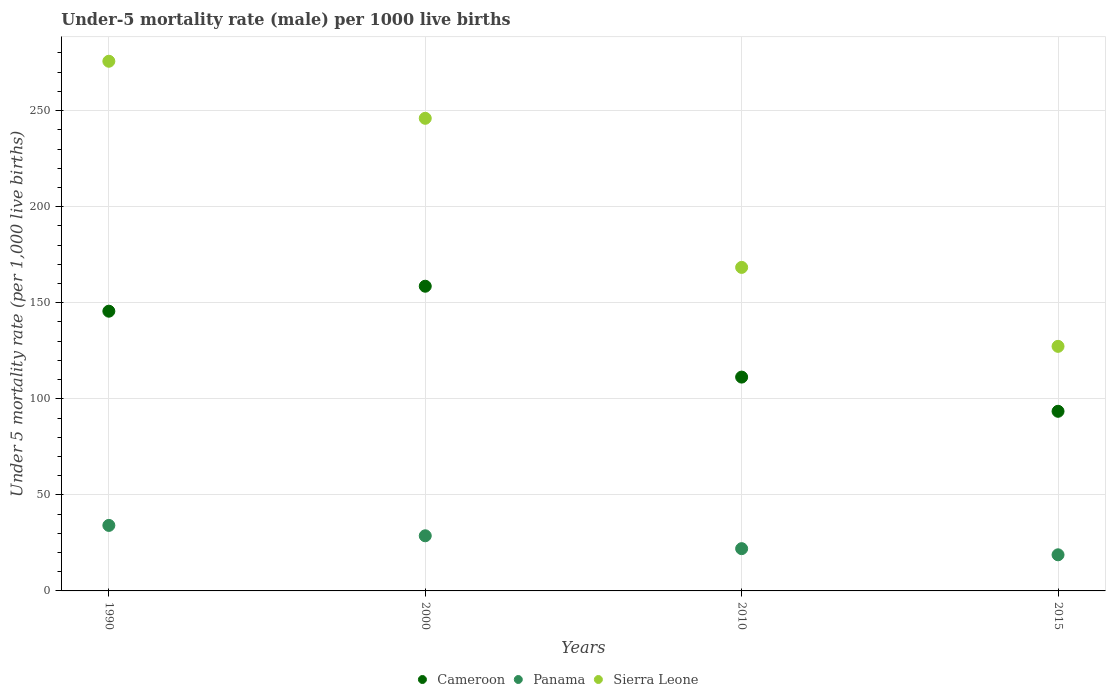Is the number of dotlines equal to the number of legend labels?
Your response must be concise. Yes. What is the under-five mortality rate in Panama in 2015?
Provide a succinct answer. 18.8. Across all years, what is the maximum under-five mortality rate in Panama?
Offer a terse response. 34.1. Across all years, what is the minimum under-five mortality rate in Cameroon?
Provide a succinct answer. 93.5. In which year was the under-five mortality rate in Cameroon minimum?
Keep it short and to the point. 2015. What is the total under-five mortality rate in Cameroon in the graph?
Your answer should be very brief. 509. What is the difference between the under-five mortality rate in Sierra Leone in 1990 and that in 2000?
Provide a succinct answer. 29.7. What is the difference between the under-five mortality rate in Cameroon in 2015 and the under-five mortality rate in Panama in 1990?
Provide a short and direct response. 59.4. What is the average under-five mortality rate in Panama per year?
Offer a terse response. 25.9. In the year 2010, what is the difference between the under-five mortality rate in Sierra Leone and under-five mortality rate in Panama?
Your response must be concise. 146.4. In how many years, is the under-five mortality rate in Cameroon greater than 130?
Your response must be concise. 2. What is the ratio of the under-five mortality rate in Cameroon in 1990 to that in 2010?
Give a very brief answer. 1.31. Is the difference between the under-five mortality rate in Sierra Leone in 2010 and 2015 greater than the difference between the under-five mortality rate in Panama in 2010 and 2015?
Offer a very short reply. Yes. What is the difference between the highest and the second highest under-five mortality rate in Sierra Leone?
Ensure brevity in your answer.  29.7. What is the difference between the highest and the lowest under-five mortality rate in Sierra Leone?
Provide a short and direct response. 148.4. In how many years, is the under-five mortality rate in Sierra Leone greater than the average under-five mortality rate in Sierra Leone taken over all years?
Offer a terse response. 2. Is the sum of the under-five mortality rate in Panama in 2010 and 2015 greater than the maximum under-five mortality rate in Cameroon across all years?
Make the answer very short. No. Is the under-five mortality rate in Panama strictly less than the under-five mortality rate in Sierra Leone over the years?
Make the answer very short. Yes. How many dotlines are there?
Your answer should be compact. 3. How many years are there in the graph?
Provide a short and direct response. 4. Does the graph contain any zero values?
Ensure brevity in your answer.  No. Does the graph contain grids?
Give a very brief answer. Yes. Where does the legend appear in the graph?
Make the answer very short. Bottom center. How many legend labels are there?
Make the answer very short. 3. How are the legend labels stacked?
Ensure brevity in your answer.  Horizontal. What is the title of the graph?
Your response must be concise. Under-5 mortality rate (male) per 1000 live births. Does "Liberia" appear as one of the legend labels in the graph?
Your answer should be compact. No. What is the label or title of the X-axis?
Offer a terse response. Years. What is the label or title of the Y-axis?
Your response must be concise. Under 5 mortality rate (per 1,0 live births). What is the Under 5 mortality rate (per 1,000 live births) of Cameroon in 1990?
Offer a terse response. 145.6. What is the Under 5 mortality rate (per 1,000 live births) in Panama in 1990?
Ensure brevity in your answer.  34.1. What is the Under 5 mortality rate (per 1,000 live births) in Sierra Leone in 1990?
Your response must be concise. 275.7. What is the Under 5 mortality rate (per 1,000 live births) of Cameroon in 2000?
Provide a succinct answer. 158.6. What is the Under 5 mortality rate (per 1,000 live births) of Panama in 2000?
Provide a succinct answer. 28.7. What is the Under 5 mortality rate (per 1,000 live births) of Sierra Leone in 2000?
Your response must be concise. 246. What is the Under 5 mortality rate (per 1,000 live births) in Cameroon in 2010?
Make the answer very short. 111.3. What is the Under 5 mortality rate (per 1,000 live births) of Sierra Leone in 2010?
Your answer should be compact. 168.4. What is the Under 5 mortality rate (per 1,000 live births) of Cameroon in 2015?
Offer a very short reply. 93.5. What is the Under 5 mortality rate (per 1,000 live births) of Panama in 2015?
Give a very brief answer. 18.8. What is the Under 5 mortality rate (per 1,000 live births) of Sierra Leone in 2015?
Ensure brevity in your answer.  127.3. Across all years, what is the maximum Under 5 mortality rate (per 1,000 live births) of Cameroon?
Ensure brevity in your answer.  158.6. Across all years, what is the maximum Under 5 mortality rate (per 1,000 live births) in Panama?
Make the answer very short. 34.1. Across all years, what is the maximum Under 5 mortality rate (per 1,000 live births) of Sierra Leone?
Offer a terse response. 275.7. Across all years, what is the minimum Under 5 mortality rate (per 1,000 live births) of Cameroon?
Your answer should be compact. 93.5. Across all years, what is the minimum Under 5 mortality rate (per 1,000 live births) of Panama?
Keep it short and to the point. 18.8. Across all years, what is the minimum Under 5 mortality rate (per 1,000 live births) of Sierra Leone?
Provide a short and direct response. 127.3. What is the total Under 5 mortality rate (per 1,000 live births) of Cameroon in the graph?
Your answer should be very brief. 509. What is the total Under 5 mortality rate (per 1,000 live births) in Panama in the graph?
Your answer should be very brief. 103.6. What is the total Under 5 mortality rate (per 1,000 live births) in Sierra Leone in the graph?
Your answer should be very brief. 817.4. What is the difference between the Under 5 mortality rate (per 1,000 live births) in Sierra Leone in 1990 and that in 2000?
Ensure brevity in your answer.  29.7. What is the difference between the Under 5 mortality rate (per 1,000 live births) in Cameroon in 1990 and that in 2010?
Keep it short and to the point. 34.3. What is the difference between the Under 5 mortality rate (per 1,000 live births) in Panama in 1990 and that in 2010?
Keep it short and to the point. 12.1. What is the difference between the Under 5 mortality rate (per 1,000 live births) of Sierra Leone in 1990 and that in 2010?
Your answer should be compact. 107.3. What is the difference between the Under 5 mortality rate (per 1,000 live births) of Cameroon in 1990 and that in 2015?
Offer a terse response. 52.1. What is the difference between the Under 5 mortality rate (per 1,000 live births) of Panama in 1990 and that in 2015?
Your answer should be very brief. 15.3. What is the difference between the Under 5 mortality rate (per 1,000 live births) in Sierra Leone in 1990 and that in 2015?
Make the answer very short. 148.4. What is the difference between the Under 5 mortality rate (per 1,000 live births) of Cameroon in 2000 and that in 2010?
Keep it short and to the point. 47.3. What is the difference between the Under 5 mortality rate (per 1,000 live births) of Sierra Leone in 2000 and that in 2010?
Give a very brief answer. 77.6. What is the difference between the Under 5 mortality rate (per 1,000 live births) of Cameroon in 2000 and that in 2015?
Make the answer very short. 65.1. What is the difference between the Under 5 mortality rate (per 1,000 live births) in Panama in 2000 and that in 2015?
Keep it short and to the point. 9.9. What is the difference between the Under 5 mortality rate (per 1,000 live births) of Sierra Leone in 2000 and that in 2015?
Your answer should be very brief. 118.7. What is the difference between the Under 5 mortality rate (per 1,000 live births) in Cameroon in 2010 and that in 2015?
Your answer should be very brief. 17.8. What is the difference between the Under 5 mortality rate (per 1,000 live births) of Panama in 2010 and that in 2015?
Offer a very short reply. 3.2. What is the difference between the Under 5 mortality rate (per 1,000 live births) of Sierra Leone in 2010 and that in 2015?
Offer a terse response. 41.1. What is the difference between the Under 5 mortality rate (per 1,000 live births) of Cameroon in 1990 and the Under 5 mortality rate (per 1,000 live births) of Panama in 2000?
Make the answer very short. 116.9. What is the difference between the Under 5 mortality rate (per 1,000 live births) of Cameroon in 1990 and the Under 5 mortality rate (per 1,000 live births) of Sierra Leone in 2000?
Your answer should be very brief. -100.4. What is the difference between the Under 5 mortality rate (per 1,000 live births) of Panama in 1990 and the Under 5 mortality rate (per 1,000 live births) of Sierra Leone in 2000?
Ensure brevity in your answer.  -211.9. What is the difference between the Under 5 mortality rate (per 1,000 live births) in Cameroon in 1990 and the Under 5 mortality rate (per 1,000 live births) in Panama in 2010?
Offer a terse response. 123.6. What is the difference between the Under 5 mortality rate (per 1,000 live births) in Cameroon in 1990 and the Under 5 mortality rate (per 1,000 live births) in Sierra Leone in 2010?
Give a very brief answer. -22.8. What is the difference between the Under 5 mortality rate (per 1,000 live births) in Panama in 1990 and the Under 5 mortality rate (per 1,000 live births) in Sierra Leone in 2010?
Your response must be concise. -134.3. What is the difference between the Under 5 mortality rate (per 1,000 live births) in Cameroon in 1990 and the Under 5 mortality rate (per 1,000 live births) in Panama in 2015?
Your answer should be very brief. 126.8. What is the difference between the Under 5 mortality rate (per 1,000 live births) in Panama in 1990 and the Under 5 mortality rate (per 1,000 live births) in Sierra Leone in 2015?
Your response must be concise. -93.2. What is the difference between the Under 5 mortality rate (per 1,000 live births) of Cameroon in 2000 and the Under 5 mortality rate (per 1,000 live births) of Panama in 2010?
Ensure brevity in your answer.  136.6. What is the difference between the Under 5 mortality rate (per 1,000 live births) of Cameroon in 2000 and the Under 5 mortality rate (per 1,000 live births) of Sierra Leone in 2010?
Give a very brief answer. -9.8. What is the difference between the Under 5 mortality rate (per 1,000 live births) of Panama in 2000 and the Under 5 mortality rate (per 1,000 live births) of Sierra Leone in 2010?
Ensure brevity in your answer.  -139.7. What is the difference between the Under 5 mortality rate (per 1,000 live births) in Cameroon in 2000 and the Under 5 mortality rate (per 1,000 live births) in Panama in 2015?
Provide a succinct answer. 139.8. What is the difference between the Under 5 mortality rate (per 1,000 live births) in Cameroon in 2000 and the Under 5 mortality rate (per 1,000 live births) in Sierra Leone in 2015?
Offer a terse response. 31.3. What is the difference between the Under 5 mortality rate (per 1,000 live births) in Panama in 2000 and the Under 5 mortality rate (per 1,000 live births) in Sierra Leone in 2015?
Your answer should be compact. -98.6. What is the difference between the Under 5 mortality rate (per 1,000 live births) in Cameroon in 2010 and the Under 5 mortality rate (per 1,000 live births) in Panama in 2015?
Keep it short and to the point. 92.5. What is the difference between the Under 5 mortality rate (per 1,000 live births) of Cameroon in 2010 and the Under 5 mortality rate (per 1,000 live births) of Sierra Leone in 2015?
Your answer should be compact. -16. What is the difference between the Under 5 mortality rate (per 1,000 live births) in Panama in 2010 and the Under 5 mortality rate (per 1,000 live births) in Sierra Leone in 2015?
Offer a terse response. -105.3. What is the average Under 5 mortality rate (per 1,000 live births) in Cameroon per year?
Give a very brief answer. 127.25. What is the average Under 5 mortality rate (per 1,000 live births) of Panama per year?
Give a very brief answer. 25.9. What is the average Under 5 mortality rate (per 1,000 live births) in Sierra Leone per year?
Your answer should be compact. 204.35. In the year 1990, what is the difference between the Under 5 mortality rate (per 1,000 live births) in Cameroon and Under 5 mortality rate (per 1,000 live births) in Panama?
Your answer should be very brief. 111.5. In the year 1990, what is the difference between the Under 5 mortality rate (per 1,000 live births) of Cameroon and Under 5 mortality rate (per 1,000 live births) of Sierra Leone?
Offer a terse response. -130.1. In the year 1990, what is the difference between the Under 5 mortality rate (per 1,000 live births) in Panama and Under 5 mortality rate (per 1,000 live births) in Sierra Leone?
Your answer should be compact. -241.6. In the year 2000, what is the difference between the Under 5 mortality rate (per 1,000 live births) in Cameroon and Under 5 mortality rate (per 1,000 live births) in Panama?
Provide a short and direct response. 129.9. In the year 2000, what is the difference between the Under 5 mortality rate (per 1,000 live births) of Cameroon and Under 5 mortality rate (per 1,000 live births) of Sierra Leone?
Make the answer very short. -87.4. In the year 2000, what is the difference between the Under 5 mortality rate (per 1,000 live births) of Panama and Under 5 mortality rate (per 1,000 live births) of Sierra Leone?
Give a very brief answer. -217.3. In the year 2010, what is the difference between the Under 5 mortality rate (per 1,000 live births) in Cameroon and Under 5 mortality rate (per 1,000 live births) in Panama?
Ensure brevity in your answer.  89.3. In the year 2010, what is the difference between the Under 5 mortality rate (per 1,000 live births) in Cameroon and Under 5 mortality rate (per 1,000 live births) in Sierra Leone?
Your answer should be compact. -57.1. In the year 2010, what is the difference between the Under 5 mortality rate (per 1,000 live births) in Panama and Under 5 mortality rate (per 1,000 live births) in Sierra Leone?
Offer a very short reply. -146.4. In the year 2015, what is the difference between the Under 5 mortality rate (per 1,000 live births) in Cameroon and Under 5 mortality rate (per 1,000 live births) in Panama?
Your answer should be very brief. 74.7. In the year 2015, what is the difference between the Under 5 mortality rate (per 1,000 live births) of Cameroon and Under 5 mortality rate (per 1,000 live births) of Sierra Leone?
Make the answer very short. -33.8. In the year 2015, what is the difference between the Under 5 mortality rate (per 1,000 live births) in Panama and Under 5 mortality rate (per 1,000 live births) in Sierra Leone?
Provide a short and direct response. -108.5. What is the ratio of the Under 5 mortality rate (per 1,000 live births) in Cameroon in 1990 to that in 2000?
Offer a very short reply. 0.92. What is the ratio of the Under 5 mortality rate (per 1,000 live births) of Panama in 1990 to that in 2000?
Offer a very short reply. 1.19. What is the ratio of the Under 5 mortality rate (per 1,000 live births) in Sierra Leone in 1990 to that in 2000?
Your answer should be compact. 1.12. What is the ratio of the Under 5 mortality rate (per 1,000 live births) in Cameroon in 1990 to that in 2010?
Your response must be concise. 1.31. What is the ratio of the Under 5 mortality rate (per 1,000 live births) of Panama in 1990 to that in 2010?
Provide a short and direct response. 1.55. What is the ratio of the Under 5 mortality rate (per 1,000 live births) of Sierra Leone in 1990 to that in 2010?
Ensure brevity in your answer.  1.64. What is the ratio of the Under 5 mortality rate (per 1,000 live births) in Cameroon in 1990 to that in 2015?
Offer a terse response. 1.56. What is the ratio of the Under 5 mortality rate (per 1,000 live births) in Panama in 1990 to that in 2015?
Provide a succinct answer. 1.81. What is the ratio of the Under 5 mortality rate (per 1,000 live births) of Sierra Leone in 1990 to that in 2015?
Make the answer very short. 2.17. What is the ratio of the Under 5 mortality rate (per 1,000 live births) in Cameroon in 2000 to that in 2010?
Your response must be concise. 1.43. What is the ratio of the Under 5 mortality rate (per 1,000 live births) in Panama in 2000 to that in 2010?
Your answer should be compact. 1.3. What is the ratio of the Under 5 mortality rate (per 1,000 live births) in Sierra Leone in 2000 to that in 2010?
Keep it short and to the point. 1.46. What is the ratio of the Under 5 mortality rate (per 1,000 live births) in Cameroon in 2000 to that in 2015?
Ensure brevity in your answer.  1.7. What is the ratio of the Under 5 mortality rate (per 1,000 live births) in Panama in 2000 to that in 2015?
Give a very brief answer. 1.53. What is the ratio of the Under 5 mortality rate (per 1,000 live births) in Sierra Leone in 2000 to that in 2015?
Keep it short and to the point. 1.93. What is the ratio of the Under 5 mortality rate (per 1,000 live births) in Cameroon in 2010 to that in 2015?
Keep it short and to the point. 1.19. What is the ratio of the Under 5 mortality rate (per 1,000 live births) of Panama in 2010 to that in 2015?
Provide a short and direct response. 1.17. What is the ratio of the Under 5 mortality rate (per 1,000 live births) in Sierra Leone in 2010 to that in 2015?
Offer a terse response. 1.32. What is the difference between the highest and the second highest Under 5 mortality rate (per 1,000 live births) of Panama?
Offer a terse response. 5.4. What is the difference between the highest and the second highest Under 5 mortality rate (per 1,000 live births) in Sierra Leone?
Provide a succinct answer. 29.7. What is the difference between the highest and the lowest Under 5 mortality rate (per 1,000 live births) of Cameroon?
Offer a very short reply. 65.1. What is the difference between the highest and the lowest Under 5 mortality rate (per 1,000 live births) in Panama?
Provide a short and direct response. 15.3. What is the difference between the highest and the lowest Under 5 mortality rate (per 1,000 live births) in Sierra Leone?
Your answer should be compact. 148.4. 